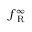Convert formula to latex. <formula><loc_0><loc_0><loc_500><loc_500>f _ { R } ^ { \infty }</formula> 